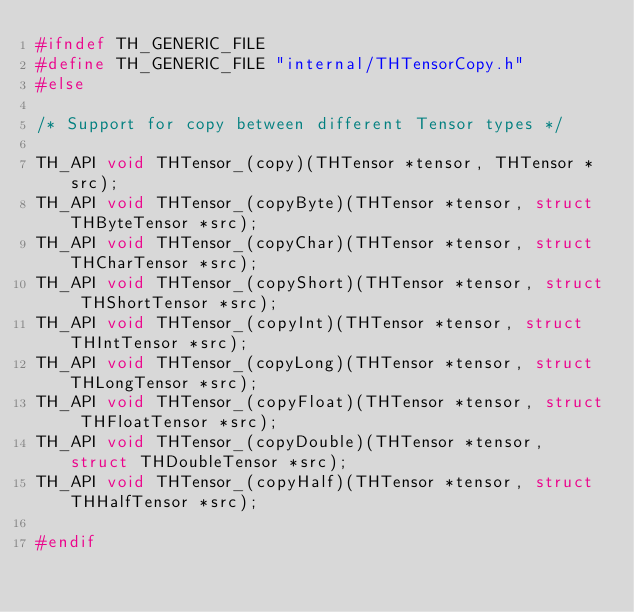Convert code to text. <code><loc_0><loc_0><loc_500><loc_500><_C_>#ifndef TH_GENERIC_FILE
#define TH_GENERIC_FILE "internal/THTensorCopy.h"
#else

/* Support for copy between different Tensor types */

TH_API void THTensor_(copy)(THTensor *tensor, THTensor *src);
TH_API void THTensor_(copyByte)(THTensor *tensor, struct THByteTensor *src);
TH_API void THTensor_(copyChar)(THTensor *tensor, struct THCharTensor *src);
TH_API void THTensor_(copyShort)(THTensor *tensor, struct THShortTensor *src);
TH_API void THTensor_(copyInt)(THTensor *tensor, struct THIntTensor *src);
TH_API void THTensor_(copyLong)(THTensor *tensor, struct THLongTensor *src);
TH_API void THTensor_(copyFloat)(THTensor *tensor, struct THFloatTensor *src);
TH_API void THTensor_(copyDouble)(THTensor *tensor, struct THDoubleTensor *src);
TH_API void THTensor_(copyHalf)(THTensor *tensor, struct THHalfTensor *src);

#endif
</code> 